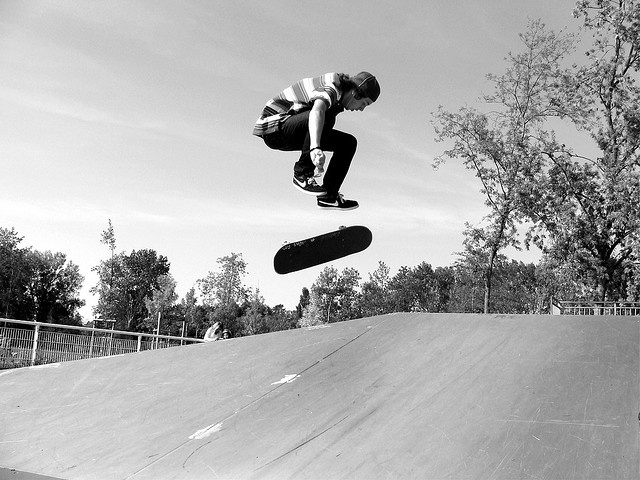Describe the objects in this image and their specific colors. I can see people in darkgray, black, white, and gray tones, skateboard in darkgray, black, white, and gray tones, and people in darkgray, white, gray, and black tones in this image. 